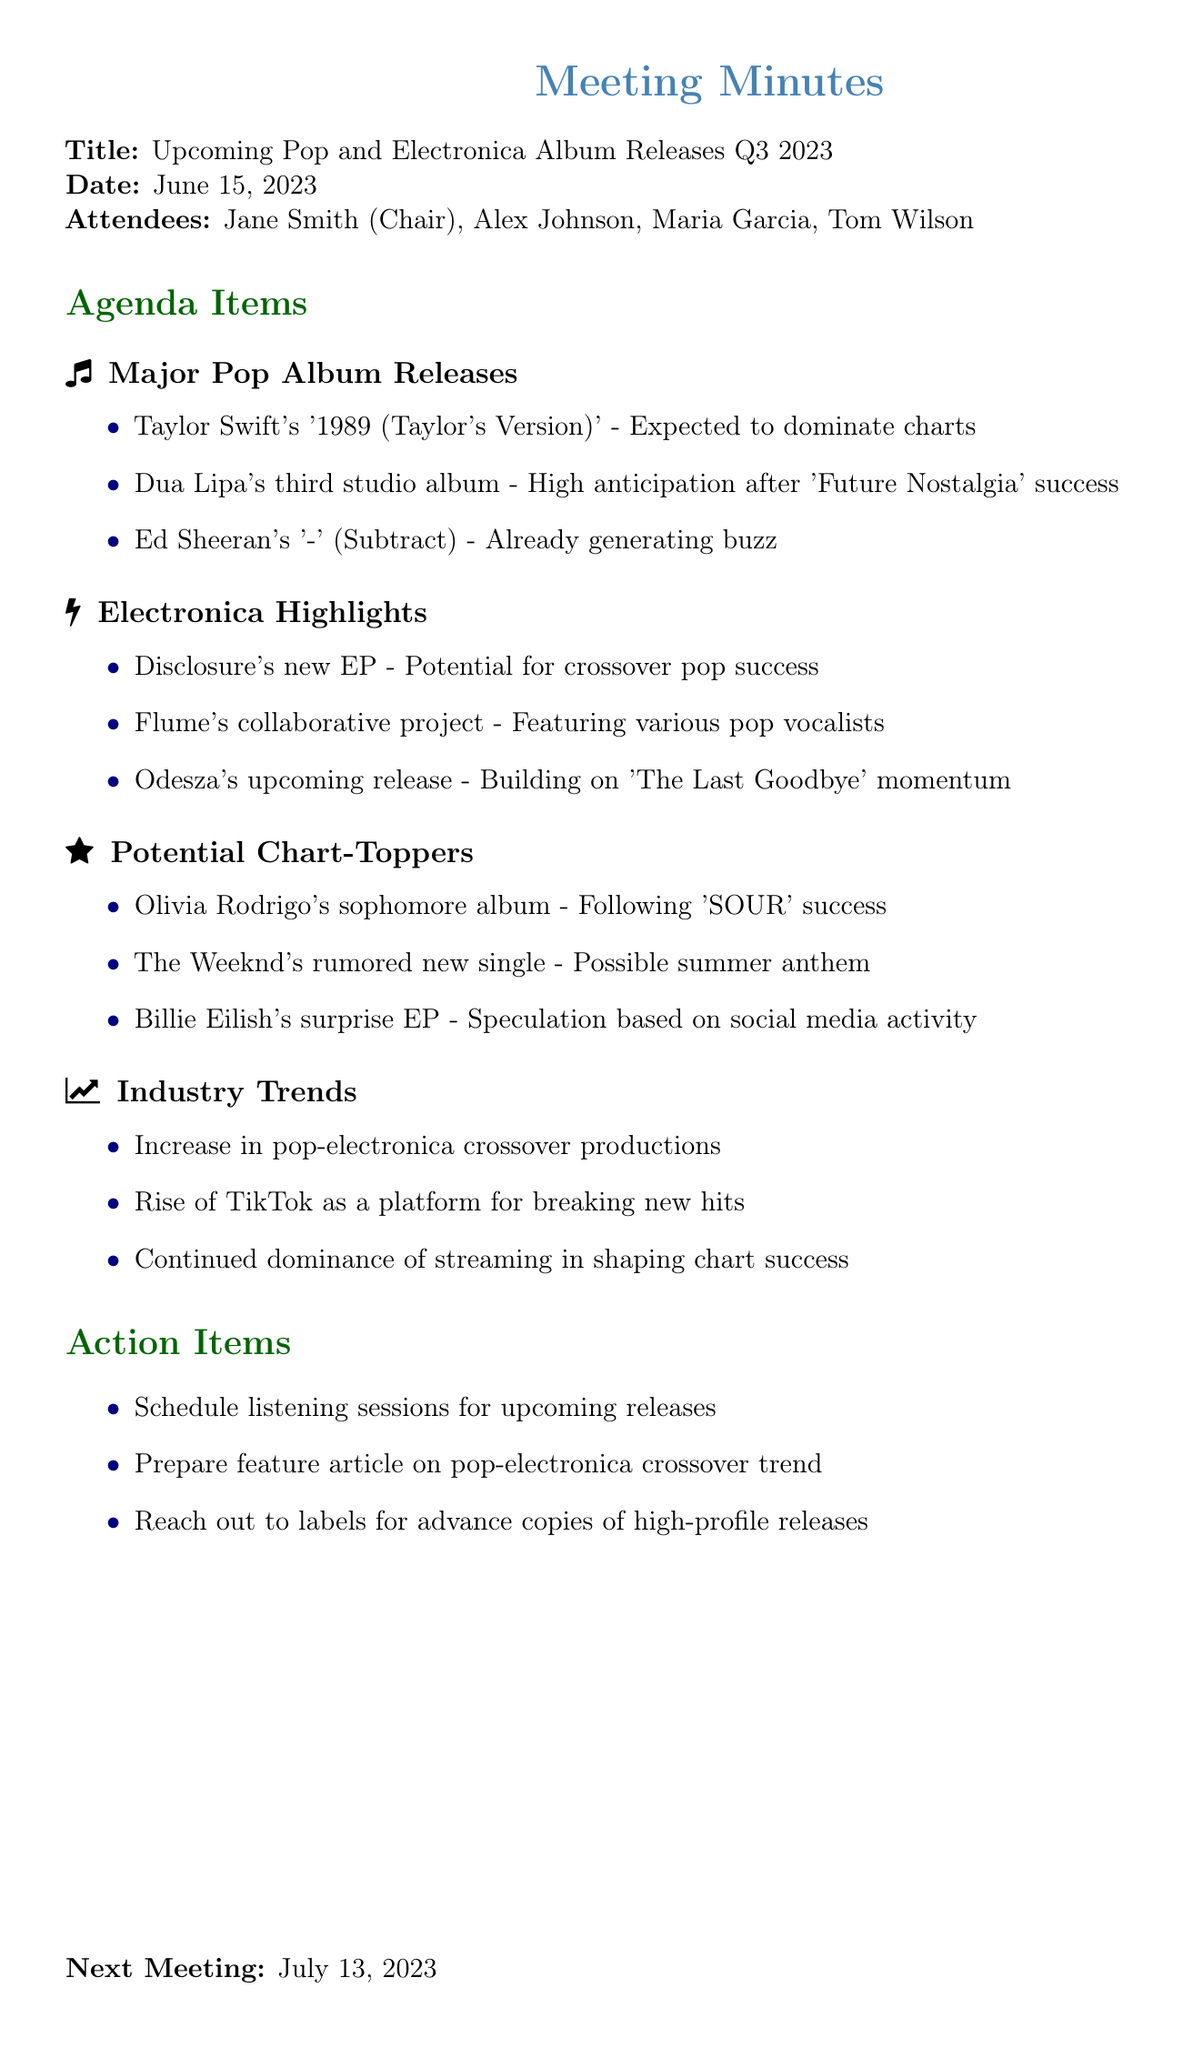What is the date of the meeting? The document specifies that the meeting took place on June 15, 2023.
Answer: June 15, 2023 Who is the chair of the meeting? Jane Smith is listed as the chair in the attendees section of the document.
Answer: Jane Smith Which album is expected to dominate the charts? The document mentions Taylor Swift's '1989 (Taylor's Version)' as expected to dominate charts.
Answer: '1989 (Taylor's Version)' What is a potential summer anthem mentioned in the meeting? The Weeknd's rumored new single is noted as a possible summer anthem.
Answer: The Weeknd's rumored new single What is one trend in the industry noted during the meeting? The minutes indicate an increase in pop-electronica crossover productions as a trend.
Answer: Increase in pop-electronica crossover productions What album follows Olivia Rodrigo's 'SOUR' success? The document states that Olivia Rodrigo's sophomore album follows the success of 'SOUR'.
Answer: Sophomore album When is the next meeting scheduled? The minutes list the next meeting date as July 13, 2023.
Answer: July 13, 2023 Which artist has a collaborative project mentioned in the discussions? Flume's collaborative project featuring various pop vocalists is mentioned in the electronica highlights.
Answer: Flume What action item is proposed concerning high-profile releases? The document states that there is a plan to reach out to labels for advance copies of high-profile releases.
Answer: Reach out to labels for advance copies 